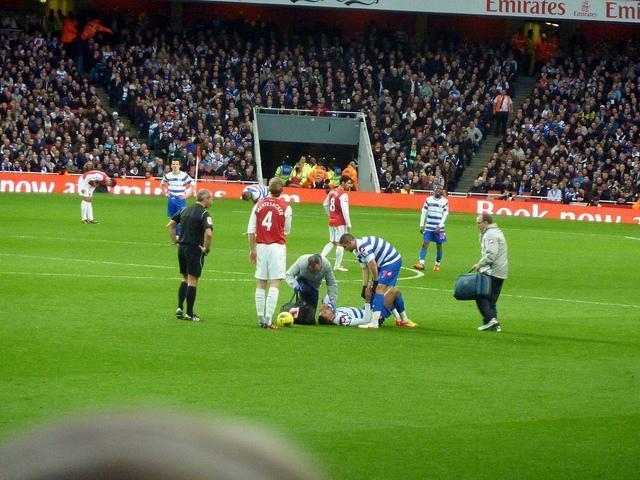How many people are visible?
Give a very brief answer. 6. How many characters on the digitized reader board on the top front of the bus are numerals?
Give a very brief answer. 0. 